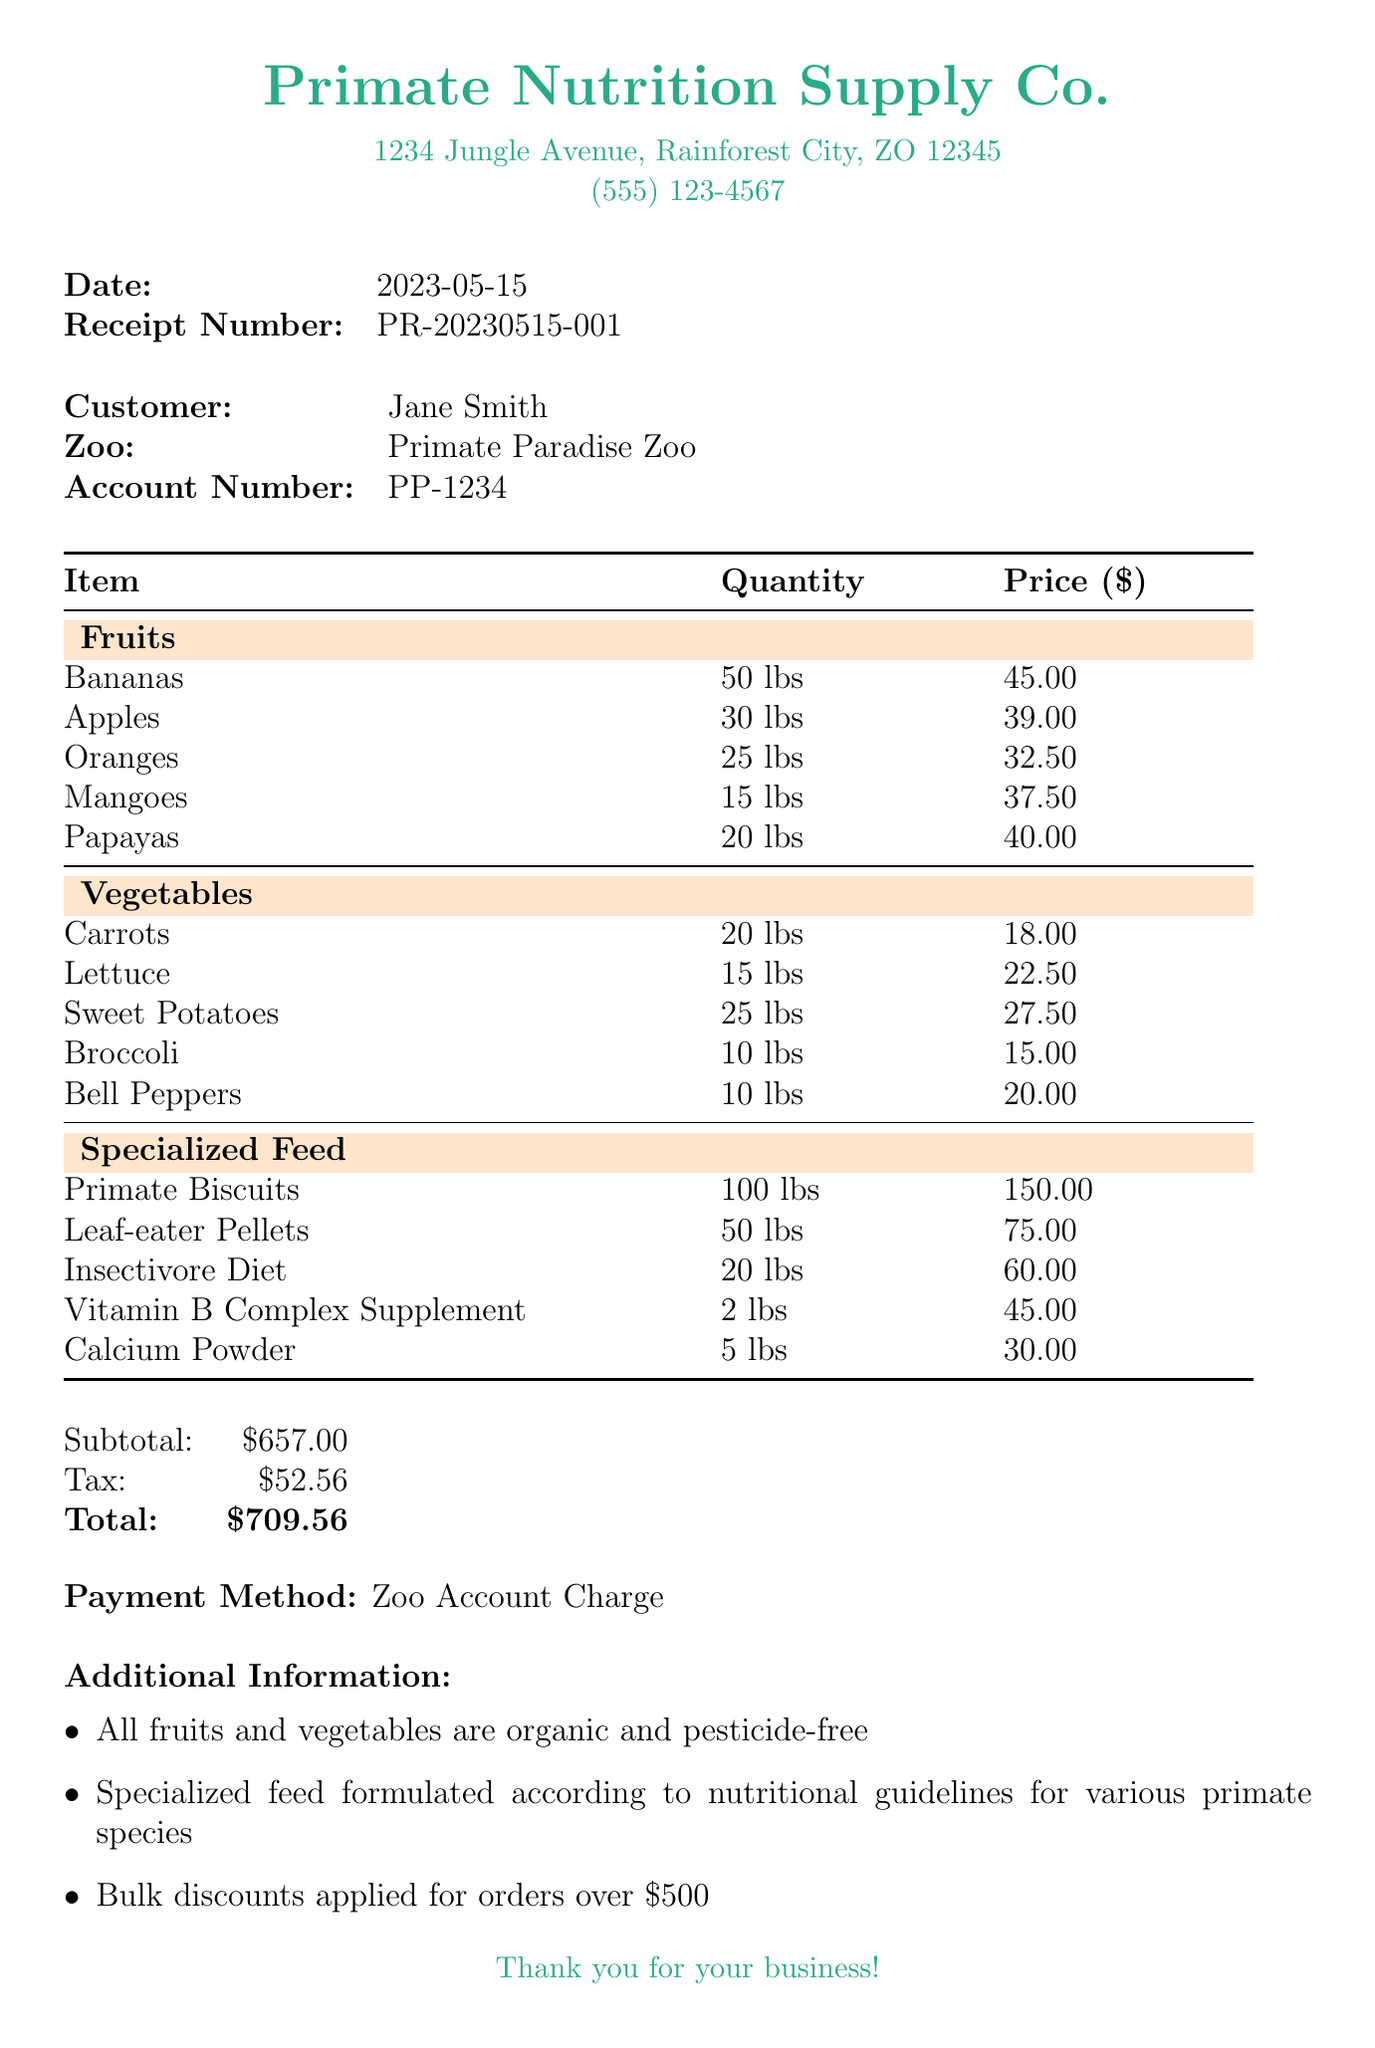What is the date of the receipt? The date is clearly mentioned in the receipt header section as the date it was issued.
Answer: 2023-05-15 What is the subtotal amount? The subtotal is indicated in the totals section of the receipt, which summarizes the costs before tax.
Answer: $657.00 Who is the customer? The customer's name is provided in the customer information section of the receipt.
Answer: Jane Smith Which category has the highest total weight? This requires reasoning over the quantities in each category to determine the total weight. Fruits has the highest combined weight: 50 + 30 + 25 + 15 + 20 = 140 lbs.
Answer: Fruits What is the total charge including tax? The total is the sum of the subtotal and tax, which is stated in the totals section of the receipt.
Answer: $709.56 What items are classified under Specialized Feed? This question looks for specific items listed in the Specialized Feed category.
Answer: Primate Biscuits, Leaf-eater Pellets, Insectivore Diet, Vitamin B Complex Supplement, Calcium Powder What payment method was used? The payment method, which indicates how the transaction was processed, is mentioned at the end of the receipt.
Answer: Zoo Account Charge Are all the fruits organic? The additional information section states whether the fruits and vegetables meet this criterion.
Answer: Yes 